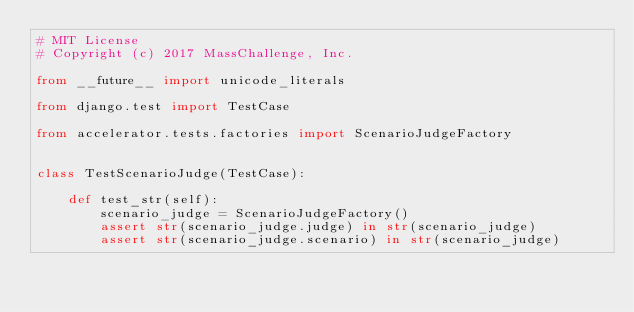<code> <loc_0><loc_0><loc_500><loc_500><_Python_># MIT License
# Copyright (c) 2017 MassChallenge, Inc.

from __future__ import unicode_literals

from django.test import TestCase

from accelerator.tests.factories import ScenarioJudgeFactory


class TestScenarioJudge(TestCase):

    def test_str(self):
        scenario_judge = ScenarioJudgeFactory()
        assert str(scenario_judge.judge) in str(scenario_judge)
        assert str(scenario_judge.scenario) in str(scenario_judge)
</code> 